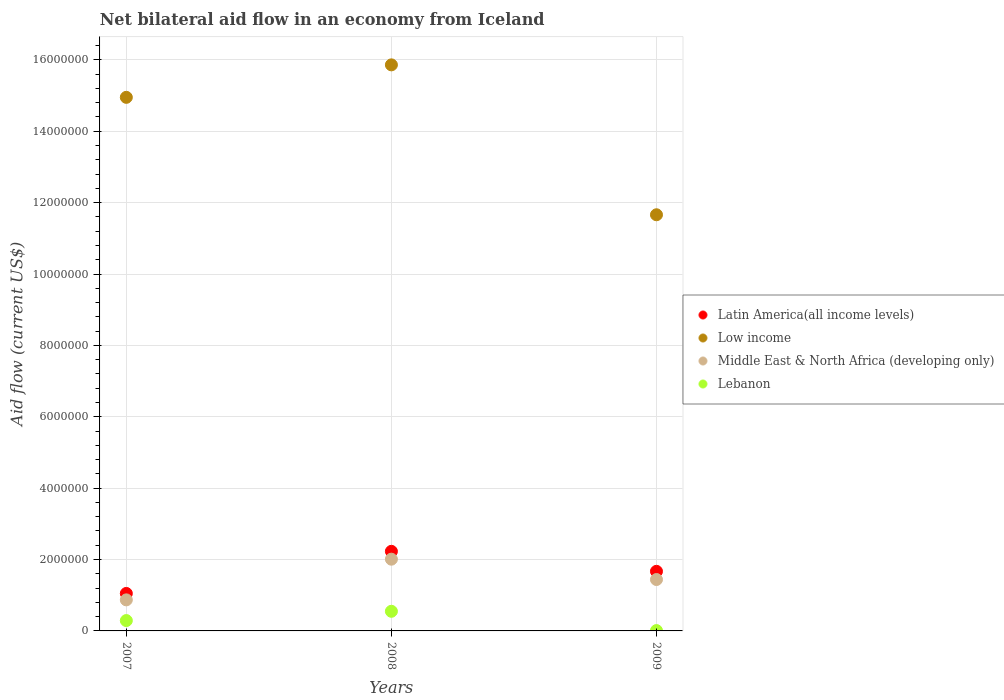Is the number of dotlines equal to the number of legend labels?
Give a very brief answer. Yes. What is the net bilateral aid flow in Latin America(all income levels) in 2008?
Make the answer very short. 2.23e+06. In which year was the net bilateral aid flow in Middle East & North Africa (developing only) maximum?
Make the answer very short. 2008. What is the total net bilateral aid flow in Middle East & North Africa (developing only) in the graph?
Provide a succinct answer. 4.32e+06. What is the difference between the net bilateral aid flow in Latin America(all income levels) in 2007 and that in 2009?
Keep it short and to the point. -6.20e+05. What is the difference between the net bilateral aid flow in Middle East & North Africa (developing only) in 2008 and the net bilateral aid flow in Low income in 2007?
Your response must be concise. -1.29e+07. What is the average net bilateral aid flow in Low income per year?
Keep it short and to the point. 1.42e+07. In the year 2007, what is the difference between the net bilateral aid flow in Low income and net bilateral aid flow in Middle East & North Africa (developing only)?
Provide a short and direct response. 1.41e+07. In how many years, is the net bilateral aid flow in Middle East & North Africa (developing only) greater than 14400000 US$?
Your answer should be very brief. 0. Is the difference between the net bilateral aid flow in Low income in 2007 and 2009 greater than the difference between the net bilateral aid flow in Middle East & North Africa (developing only) in 2007 and 2009?
Keep it short and to the point. Yes. What is the difference between the highest and the second highest net bilateral aid flow in Middle East & North Africa (developing only)?
Ensure brevity in your answer.  5.70e+05. What is the difference between the highest and the lowest net bilateral aid flow in Middle East & North Africa (developing only)?
Make the answer very short. 1.14e+06. In how many years, is the net bilateral aid flow in Low income greater than the average net bilateral aid flow in Low income taken over all years?
Your response must be concise. 2. Is it the case that in every year, the sum of the net bilateral aid flow in Lebanon and net bilateral aid flow in Middle East & North Africa (developing only)  is greater than the sum of net bilateral aid flow in Latin America(all income levels) and net bilateral aid flow in Low income?
Provide a short and direct response. No. Is the net bilateral aid flow in Low income strictly less than the net bilateral aid flow in Middle East & North Africa (developing only) over the years?
Provide a succinct answer. No. What is the difference between two consecutive major ticks on the Y-axis?
Your response must be concise. 2.00e+06. Are the values on the major ticks of Y-axis written in scientific E-notation?
Keep it short and to the point. No. Does the graph contain any zero values?
Your response must be concise. No. Where does the legend appear in the graph?
Provide a succinct answer. Center right. What is the title of the graph?
Offer a terse response. Net bilateral aid flow in an economy from Iceland. Does "Mongolia" appear as one of the legend labels in the graph?
Keep it short and to the point. No. What is the label or title of the X-axis?
Offer a very short reply. Years. What is the Aid flow (current US$) in Latin America(all income levels) in 2007?
Your response must be concise. 1.05e+06. What is the Aid flow (current US$) of Low income in 2007?
Your response must be concise. 1.50e+07. What is the Aid flow (current US$) in Middle East & North Africa (developing only) in 2007?
Ensure brevity in your answer.  8.70e+05. What is the Aid flow (current US$) in Latin America(all income levels) in 2008?
Your answer should be compact. 2.23e+06. What is the Aid flow (current US$) of Low income in 2008?
Provide a succinct answer. 1.59e+07. What is the Aid flow (current US$) in Middle East & North Africa (developing only) in 2008?
Provide a short and direct response. 2.01e+06. What is the Aid flow (current US$) in Latin America(all income levels) in 2009?
Provide a short and direct response. 1.67e+06. What is the Aid flow (current US$) in Low income in 2009?
Your answer should be compact. 1.17e+07. What is the Aid flow (current US$) of Middle East & North Africa (developing only) in 2009?
Your answer should be very brief. 1.44e+06. Across all years, what is the maximum Aid flow (current US$) in Latin America(all income levels)?
Make the answer very short. 2.23e+06. Across all years, what is the maximum Aid flow (current US$) in Low income?
Your answer should be compact. 1.59e+07. Across all years, what is the maximum Aid flow (current US$) of Middle East & North Africa (developing only)?
Your answer should be compact. 2.01e+06. Across all years, what is the maximum Aid flow (current US$) of Lebanon?
Offer a terse response. 5.50e+05. Across all years, what is the minimum Aid flow (current US$) of Latin America(all income levels)?
Keep it short and to the point. 1.05e+06. Across all years, what is the minimum Aid flow (current US$) of Low income?
Make the answer very short. 1.17e+07. Across all years, what is the minimum Aid flow (current US$) in Middle East & North Africa (developing only)?
Ensure brevity in your answer.  8.70e+05. What is the total Aid flow (current US$) of Latin America(all income levels) in the graph?
Your answer should be compact. 4.95e+06. What is the total Aid flow (current US$) of Low income in the graph?
Your answer should be very brief. 4.25e+07. What is the total Aid flow (current US$) in Middle East & North Africa (developing only) in the graph?
Give a very brief answer. 4.32e+06. What is the total Aid flow (current US$) in Lebanon in the graph?
Keep it short and to the point. 8.50e+05. What is the difference between the Aid flow (current US$) of Latin America(all income levels) in 2007 and that in 2008?
Provide a succinct answer. -1.18e+06. What is the difference between the Aid flow (current US$) of Low income in 2007 and that in 2008?
Make the answer very short. -9.10e+05. What is the difference between the Aid flow (current US$) of Middle East & North Africa (developing only) in 2007 and that in 2008?
Keep it short and to the point. -1.14e+06. What is the difference between the Aid flow (current US$) of Latin America(all income levels) in 2007 and that in 2009?
Ensure brevity in your answer.  -6.20e+05. What is the difference between the Aid flow (current US$) in Low income in 2007 and that in 2009?
Your answer should be very brief. 3.29e+06. What is the difference between the Aid flow (current US$) in Middle East & North Africa (developing only) in 2007 and that in 2009?
Ensure brevity in your answer.  -5.70e+05. What is the difference between the Aid flow (current US$) of Latin America(all income levels) in 2008 and that in 2009?
Offer a very short reply. 5.60e+05. What is the difference between the Aid flow (current US$) in Low income in 2008 and that in 2009?
Your answer should be very brief. 4.20e+06. What is the difference between the Aid flow (current US$) of Middle East & North Africa (developing only) in 2008 and that in 2009?
Offer a very short reply. 5.70e+05. What is the difference between the Aid flow (current US$) of Lebanon in 2008 and that in 2009?
Offer a terse response. 5.40e+05. What is the difference between the Aid flow (current US$) of Latin America(all income levels) in 2007 and the Aid flow (current US$) of Low income in 2008?
Provide a succinct answer. -1.48e+07. What is the difference between the Aid flow (current US$) of Latin America(all income levels) in 2007 and the Aid flow (current US$) of Middle East & North Africa (developing only) in 2008?
Keep it short and to the point. -9.60e+05. What is the difference between the Aid flow (current US$) of Latin America(all income levels) in 2007 and the Aid flow (current US$) of Lebanon in 2008?
Keep it short and to the point. 5.00e+05. What is the difference between the Aid flow (current US$) in Low income in 2007 and the Aid flow (current US$) in Middle East & North Africa (developing only) in 2008?
Provide a succinct answer. 1.29e+07. What is the difference between the Aid flow (current US$) in Low income in 2007 and the Aid flow (current US$) in Lebanon in 2008?
Make the answer very short. 1.44e+07. What is the difference between the Aid flow (current US$) in Latin America(all income levels) in 2007 and the Aid flow (current US$) in Low income in 2009?
Your response must be concise. -1.06e+07. What is the difference between the Aid flow (current US$) in Latin America(all income levels) in 2007 and the Aid flow (current US$) in Middle East & North Africa (developing only) in 2009?
Offer a terse response. -3.90e+05. What is the difference between the Aid flow (current US$) of Latin America(all income levels) in 2007 and the Aid flow (current US$) of Lebanon in 2009?
Keep it short and to the point. 1.04e+06. What is the difference between the Aid flow (current US$) in Low income in 2007 and the Aid flow (current US$) in Middle East & North Africa (developing only) in 2009?
Provide a short and direct response. 1.35e+07. What is the difference between the Aid flow (current US$) of Low income in 2007 and the Aid flow (current US$) of Lebanon in 2009?
Offer a very short reply. 1.49e+07. What is the difference between the Aid flow (current US$) in Middle East & North Africa (developing only) in 2007 and the Aid flow (current US$) in Lebanon in 2009?
Your response must be concise. 8.60e+05. What is the difference between the Aid flow (current US$) in Latin America(all income levels) in 2008 and the Aid flow (current US$) in Low income in 2009?
Your response must be concise. -9.43e+06. What is the difference between the Aid flow (current US$) of Latin America(all income levels) in 2008 and the Aid flow (current US$) of Middle East & North Africa (developing only) in 2009?
Make the answer very short. 7.90e+05. What is the difference between the Aid flow (current US$) in Latin America(all income levels) in 2008 and the Aid flow (current US$) in Lebanon in 2009?
Offer a terse response. 2.22e+06. What is the difference between the Aid flow (current US$) in Low income in 2008 and the Aid flow (current US$) in Middle East & North Africa (developing only) in 2009?
Provide a succinct answer. 1.44e+07. What is the difference between the Aid flow (current US$) of Low income in 2008 and the Aid flow (current US$) of Lebanon in 2009?
Your response must be concise. 1.58e+07. What is the average Aid flow (current US$) in Latin America(all income levels) per year?
Ensure brevity in your answer.  1.65e+06. What is the average Aid flow (current US$) of Low income per year?
Offer a very short reply. 1.42e+07. What is the average Aid flow (current US$) in Middle East & North Africa (developing only) per year?
Offer a terse response. 1.44e+06. What is the average Aid flow (current US$) in Lebanon per year?
Offer a terse response. 2.83e+05. In the year 2007, what is the difference between the Aid flow (current US$) of Latin America(all income levels) and Aid flow (current US$) of Low income?
Keep it short and to the point. -1.39e+07. In the year 2007, what is the difference between the Aid flow (current US$) in Latin America(all income levels) and Aid flow (current US$) in Lebanon?
Offer a terse response. 7.60e+05. In the year 2007, what is the difference between the Aid flow (current US$) of Low income and Aid flow (current US$) of Middle East & North Africa (developing only)?
Keep it short and to the point. 1.41e+07. In the year 2007, what is the difference between the Aid flow (current US$) of Low income and Aid flow (current US$) of Lebanon?
Make the answer very short. 1.47e+07. In the year 2007, what is the difference between the Aid flow (current US$) of Middle East & North Africa (developing only) and Aid flow (current US$) of Lebanon?
Offer a terse response. 5.80e+05. In the year 2008, what is the difference between the Aid flow (current US$) in Latin America(all income levels) and Aid flow (current US$) in Low income?
Your answer should be very brief. -1.36e+07. In the year 2008, what is the difference between the Aid flow (current US$) of Latin America(all income levels) and Aid flow (current US$) of Middle East & North Africa (developing only)?
Provide a succinct answer. 2.20e+05. In the year 2008, what is the difference between the Aid flow (current US$) in Latin America(all income levels) and Aid flow (current US$) in Lebanon?
Make the answer very short. 1.68e+06. In the year 2008, what is the difference between the Aid flow (current US$) of Low income and Aid flow (current US$) of Middle East & North Africa (developing only)?
Provide a short and direct response. 1.38e+07. In the year 2008, what is the difference between the Aid flow (current US$) of Low income and Aid flow (current US$) of Lebanon?
Give a very brief answer. 1.53e+07. In the year 2008, what is the difference between the Aid flow (current US$) in Middle East & North Africa (developing only) and Aid flow (current US$) in Lebanon?
Provide a succinct answer. 1.46e+06. In the year 2009, what is the difference between the Aid flow (current US$) in Latin America(all income levels) and Aid flow (current US$) in Low income?
Give a very brief answer. -9.99e+06. In the year 2009, what is the difference between the Aid flow (current US$) of Latin America(all income levels) and Aid flow (current US$) of Lebanon?
Your answer should be very brief. 1.66e+06. In the year 2009, what is the difference between the Aid flow (current US$) of Low income and Aid flow (current US$) of Middle East & North Africa (developing only)?
Offer a very short reply. 1.02e+07. In the year 2009, what is the difference between the Aid flow (current US$) in Low income and Aid flow (current US$) in Lebanon?
Offer a very short reply. 1.16e+07. In the year 2009, what is the difference between the Aid flow (current US$) in Middle East & North Africa (developing only) and Aid flow (current US$) in Lebanon?
Your answer should be very brief. 1.43e+06. What is the ratio of the Aid flow (current US$) in Latin America(all income levels) in 2007 to that in 2008?
Keep it short and to the point. 0.47. What is the ratio of the Aid flow (current US$) in Low income in 2007 to that in 2008?
Ensure brevity in your answer.  0.94. What is the ratio of the Aid flow (current US$) in Middle East & North Africa (developing only) in 2007 to that in 2008?
Your answer should be very brief. 0.43. What is the ratio of the Aid flow (current US$) in Lebanon in 2007 to that in 2008?
Offer a terse response. 0.53. What is the ratio of the Aid flow (current US$) of Latin America(all income levels) in 2007 to that in 2009?
Provide a succinct answer. 0.63. What is the ratio of the Aid flow (current US$) in Low income in 2007 to that in 2009?
Ensure brevity in your answer.  1.28. What is the ratio of the Aid flow (current US$) in Middle East & North Africa (developing only) in 2007 to that in 2009?
Give a very brief answer. 0.6. What is the ratio of the Aid flow (current US$) of Lebanon in 2007 to that in 2009?
Provide a succinct answer. 29. What is the ratio of the Aid flow (current US$) of Latin America(all income levels) in 2008 to that in 2009?
Keep it short and to the point. 1.34. What is the ratio of the Aid flow (current US$) in Low income in 2008 to that in 2009?
Provide a short and direct response. 1.36. What is the ratio of the Aid flow (current US$) in Middle East & North Africa (developing only) in 2008 to that in 2009?
Offer a very short reply. 1.4. What is the ratio of the Aid flow (current US$) of Lebanon in 2008 to that in 2009?
Offer a very short reply. 55. What is the difference between the highest and the second highest Aid flow (current US$) in Latin America(all income levels)?
Give a very brief answer. 5.60e+05. What is the difference between the highest and the second highest Aid flow (current US$) in Low income?
Offer a very short reply. 9.10e+05. What is the difference between the highest and the second highest Aid flow (current US$) in Middle East & North Africa (developing only)?
Give a very brief answer. 5.70e+05. What is the difference between the highest and the second highest Aid flow (current US$) of Lebanon?
Offer a terse response. 2.60e+05. What is the difference between the highest and the lowest Aid flow (current US$) of Latin America(all income levels)?
Offer a very short reply. 1.18e+06. What is the difference between the highest and the lowest Aid flow (current US$) of Low income?
Make the answer very short. 4.20e+06. What is the difference between the highest and the lowest Aid flow (current US$) of Middle East & North Africa (developing only)?
Ensure brevity in your answer.  1.14e+06. What is the difference between the highest and the lowest Aid flow (current US$) of Lebanon?
Ensure brevity in your answer.  5.40e+05. 